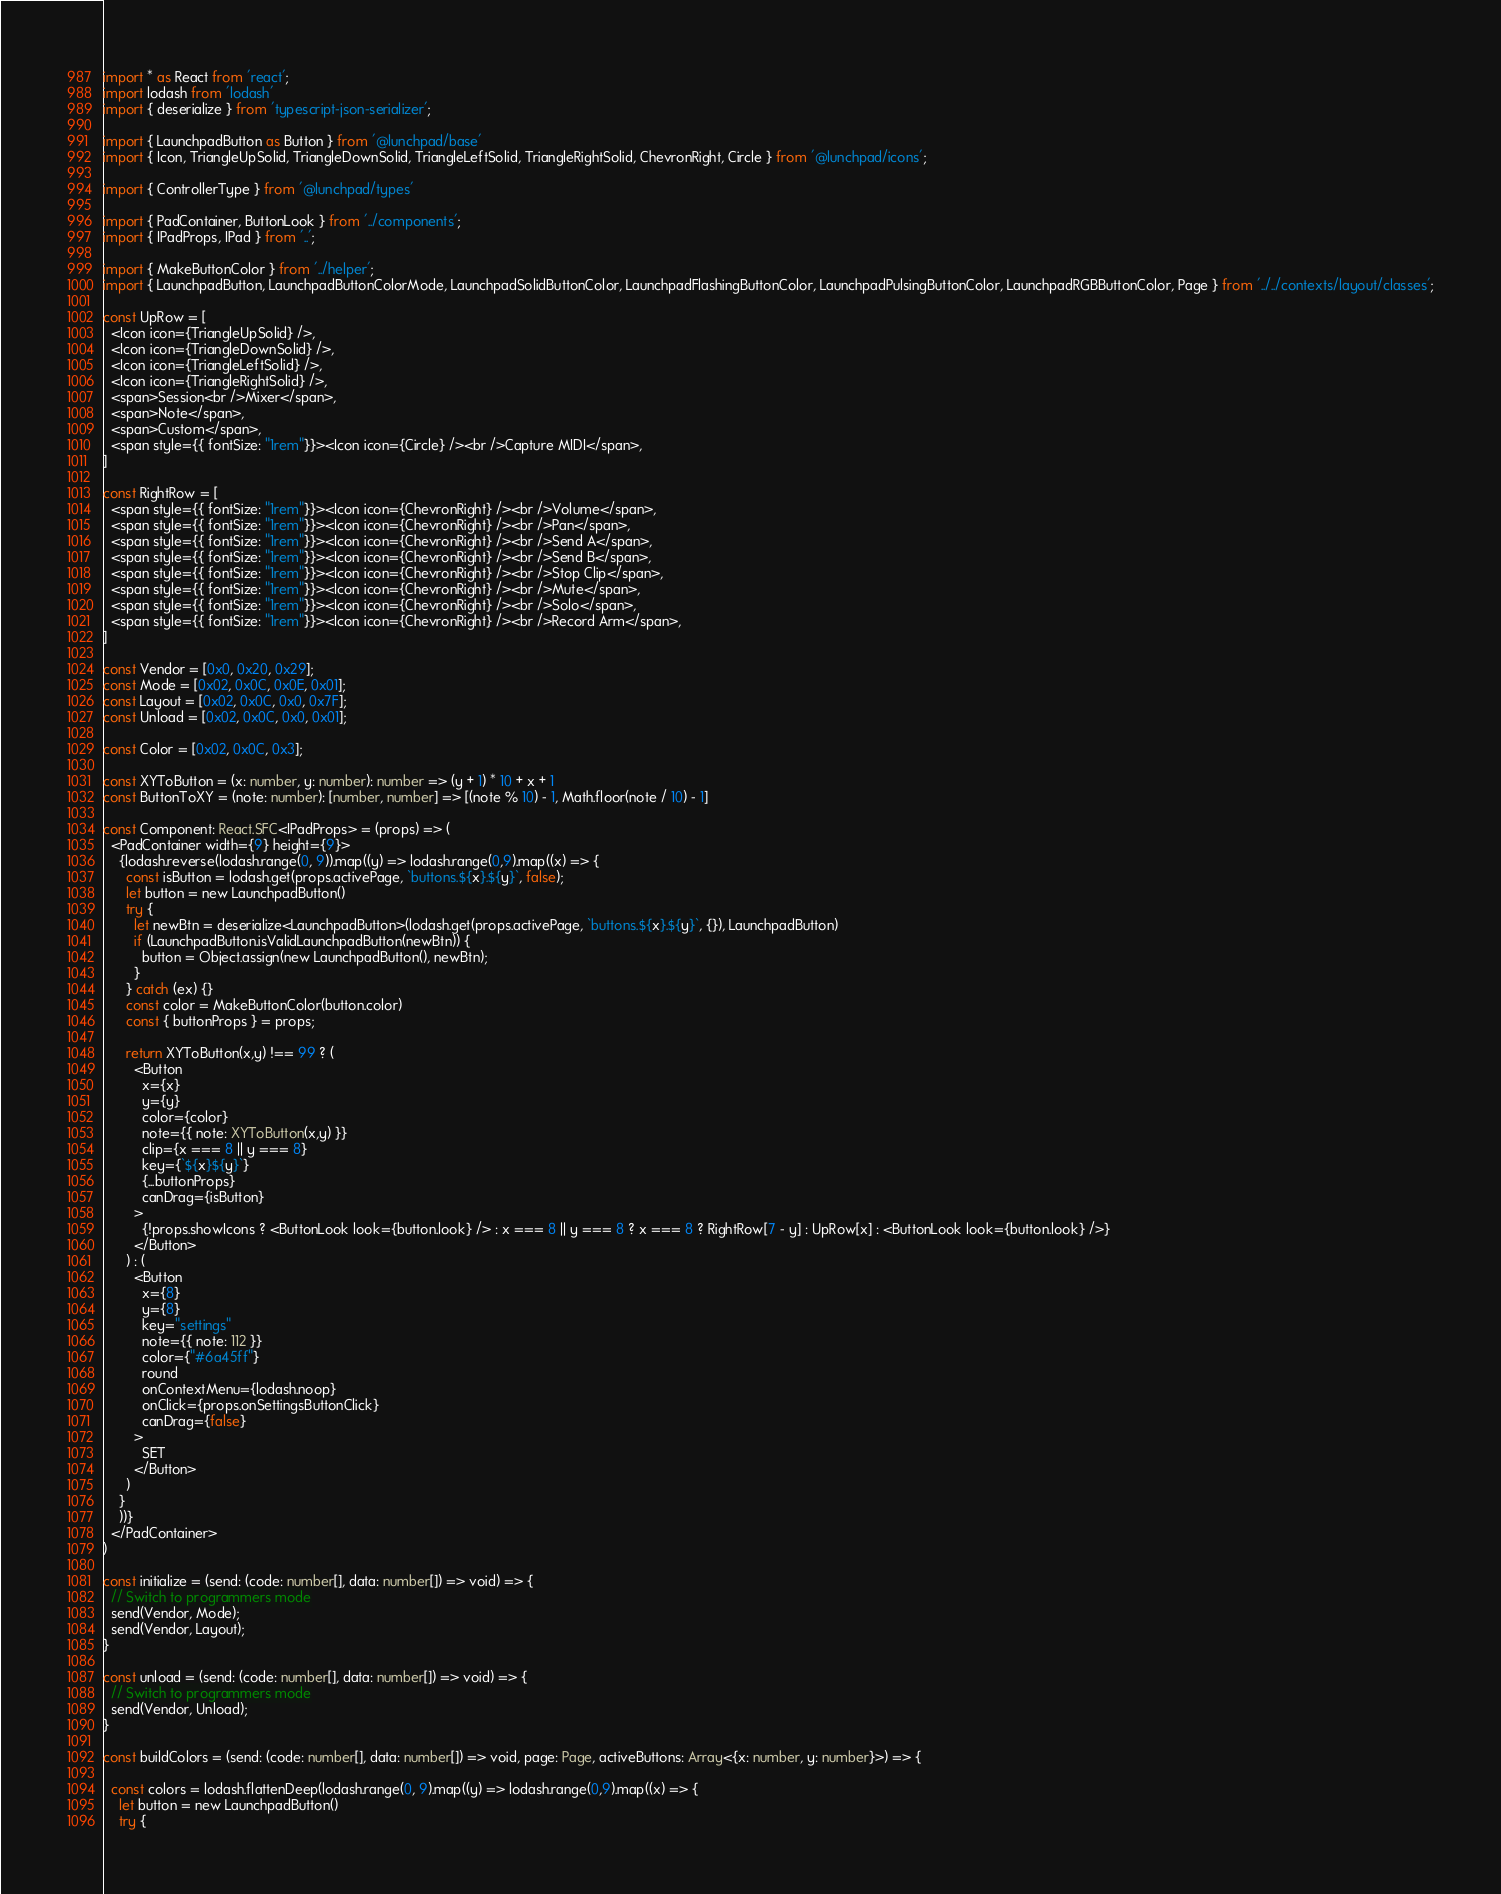<code> <loc_0><loc_0><loc_500><loc_500><_TypeScript_>import * as React from 'react';
import lodash from 'lodash'
import { deserialize } from 'typescript-json-serializer';

import { LaunchpadButton as Button } from '@lunchpad/base'
import { Icon, TriangleUpSolid, TriangleDownSolid, TriangleLeftSolid, TriangleRightSolid, ChevronRight, Circle } from '@lunchpad/icons';

import { ControllerType } from '@lunchpad/types'

import { PadContainer, ButtonLook } from '../components';
import { IPadProps, IPad } from '..';

import { MakeButtonColor } from '../helper';
import { LaunchpadButton, LaunchpadButtonColorMode, LaunchpadSolidButtonColor, LaunchpadFlashingButtonColor, LaunchpadPulsingButtonColor, LaunchpadRGBButtonColor, Page } from '../../contexts/layout/classes';

const UpRow = [
  <Icon icon={TriangleUpSolid} />,
  <Icon icon={TriangleDownSolid} />,
  <Icon icon={TriangleLeftSolid} />,
  <Icon icon={TriangleRightSolid} />,
  <span>Session<br />Mixer</span>,
  <span>Note</span>,
  <span>Custom</span>,
  <span style={{ fontSize: "1rem"}}><Icon icon={Circle} /><br />Capture MIDI</span>,
]

const RightRow = [
  <span style={{ fontSize: "1rem"}}><Icon icon={ChevronRight} /><br />Volume</span>,
  <span style={{ fontSize: "1rem"}}><Icon icon={ChevronRight} /><br />Pan</span>,
  <span style={{ fontSize: "1rem"}}><Icon icon={ChevronRight} /><br />Send A</span>,
  <span style={{ fontSize: "1rem"}}><Icon icon={ChevronRight} /><br />Send B</span>,
  <span style={{ fontSize: "1rem"}}><Icon icon={ChevronRight} /><br />Stop Clip</span>,
  <span style={{ fontSize: "1rem"}}><Icon icon={ChevronRight} /><br />Mute</span>,
  <span style={{ fontSize: "1rem"}}><Icon icon={ChevronRight} /><br />Solo</span>,
  <span style={{ fontSize: "1rem"}}><Icon icon={ChevronRight} /><br />Record Arm</span>,
]

const Vendor = [0x0, 0x20, 0x29];
const Mode = [0x02, 0x0C, 0x0E, 0x01];
const Layout = [0x02, 0x0C, 0x0, 0x7F];
const Unload = [0x02, 0x0C, 0x0, 0x01];

const Color = [0x02, 0x0C, 0x3];

const XYToButton = (x: number, y: number): number => (y + 1) * 10 + x + 1
const ButtonToXY = (note: number): [number, number] => [(note % 10) - 1, Math.floor(note / 10) - 1] 

const Component: React.SFC<IPadProps> = (props) => (
  <PadContainer width={9} height={9}>
    {lodash.reverse(lodash.range(0, 9)).map((y) => lodash.range(0,9).map((x) => {
      const isButton = lodash.get(props.activePage, `buttons.${x}.${y}`, false);
      let button = new LaunchpadButton()
      try {
        let newBtn = deserialize<LaunchpadButton>(lodash.get(props.activePage, `buttons.${x}.${y}`, {}), LaunchpadButton)
        if (LaunchpadButton.isValidLaunchpadButton(newBtn)) {
          button = Object.assign(new LaunchpadButton(), newBtn);
        }
      } catch (ex) {}
      const color = MakeButtonColor(button.color)
      const { buttonProps } = props;

      return XYToButton(x,y) !== 99 ? (
        <Button
          x={x}
          y={y}
          color={color}
          note={{ note: XYToButton(x,y) }}
          clip={x === 8 || y === 8}
          key={`${x}${y}`}
          {...buttonProps}
          canDrag={isButton}
        >
          {!props.showIcons ? <ButtonLook look={button.look} /> : x === 8 || y === 8 ? x === 8 ? RightRow[7 - y] : UpRow[x] : <ButtonLook look={button.look} />}
        </Button>
      ) : (
        <Button
          x={8}
          y={8}
          key="settings"
          note={{ note: 112 }}
          color={"#6a45ff"}
          round
          onContextMenu={lodash.noop}
          onClick={props.onSettingsButtonClick}
          canDrag={false}
        >
          SET
        </Button>
      )
    }
    ))}
  </PadContainer>
)

const initialize = (send: (code: number[], data: number[]) => void) => {
  // Switch to programmers mode
  send(Vendor, Mode);
  send(Vendor, Layout);
}

const unload = (send: (code: number[], data: number[]) => void) => {
  // Switch to programmers mode
  send(Vendor, Unload);
}

const buildColors = (send: (code: number[], data: number[]) => void, page: Page, activeButtons: Array<{x: number, y: number}>) => {
  
  const colors = lodash.flattenDeep(lodash.range(0, 9).map((y) => lodash.range(0,9).map((x) => {
    let button = new LaunchpadButton()
    try {</code> 